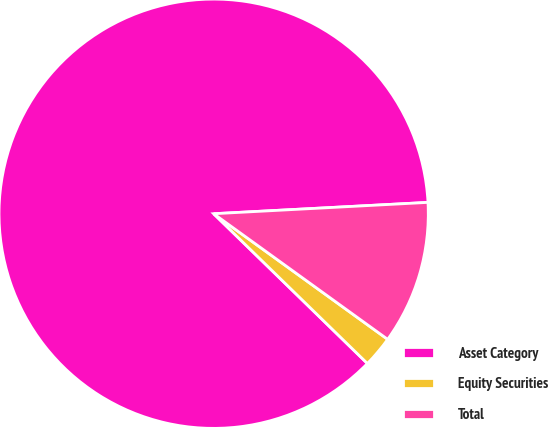<chart> <loc_0><loc_0><loc_500><loc_500><pie_chart><fcel>Asset Category<fcel>Equity Securities<fcel>Total<nl><fcel>86.86%<fcel>2.34%<fcel>10.79%<nl></chart> 